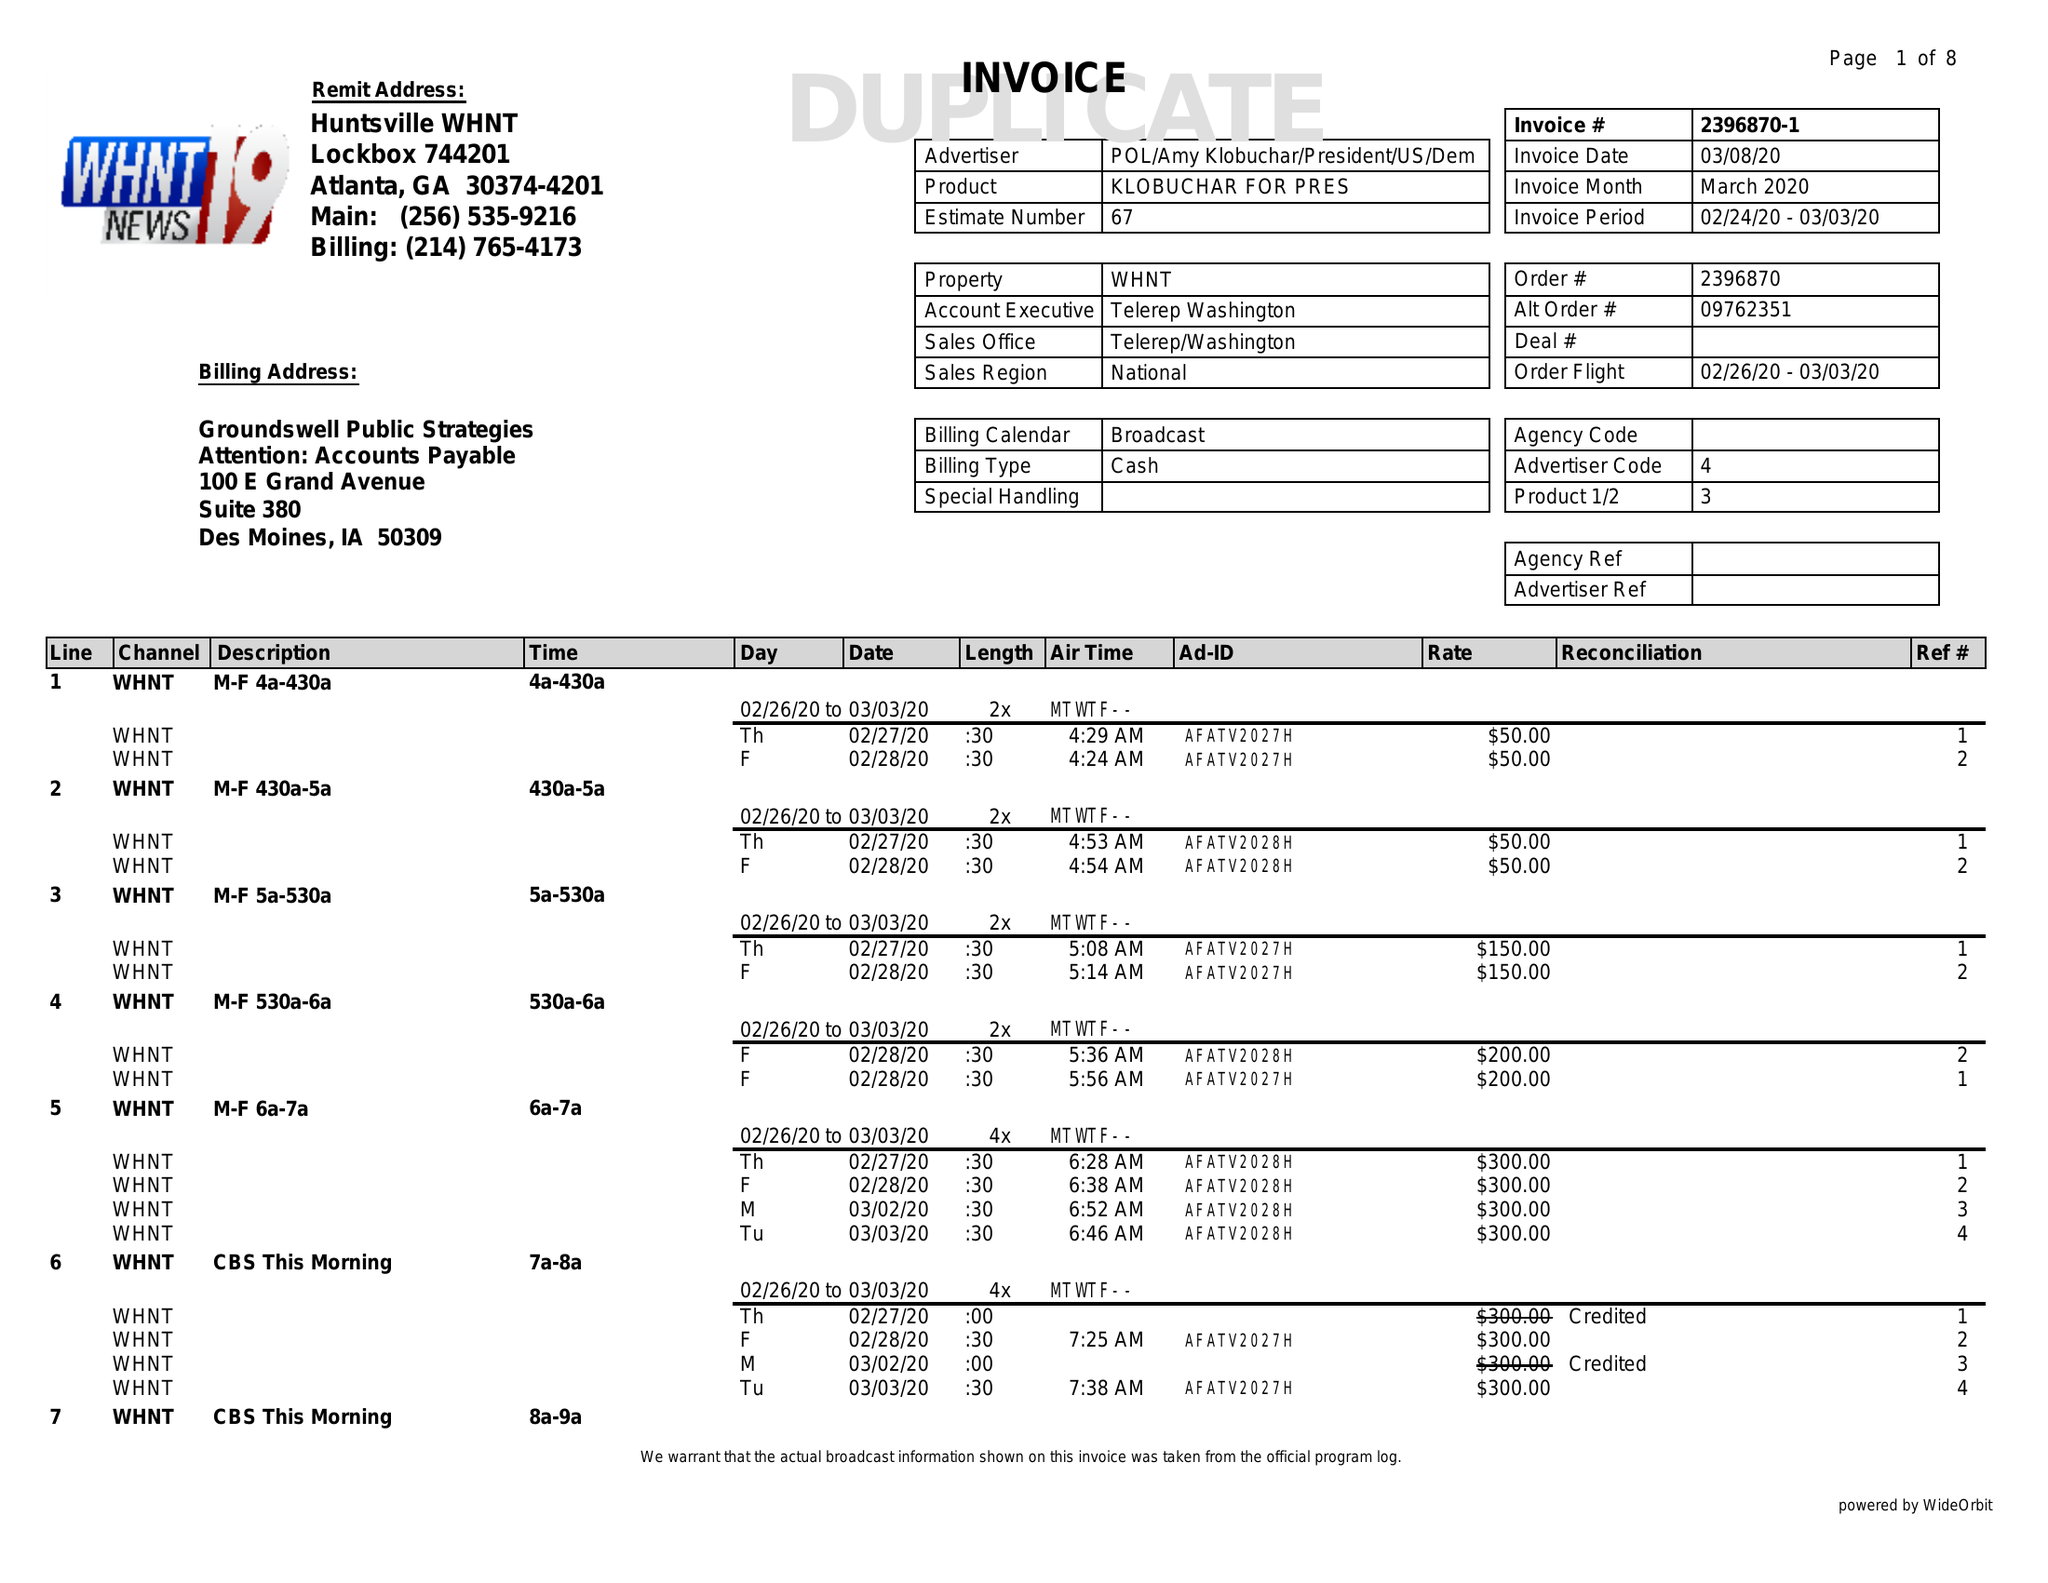What is the value for the contract_num?
Answer the question using a single word or phrase. 2396870 